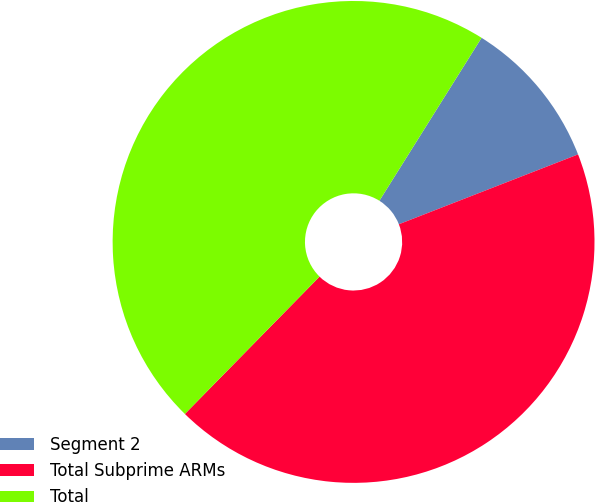Convert chart. <chart><loc_0><loc_0><loc_500><loc_500><pie_chart><fcel>Segment 2<fcel>Total Subprime ARMs<fcel>Total<nl><fcel>10.17%<fcel>43.26%<fcel>46.57%<nl></chart> 